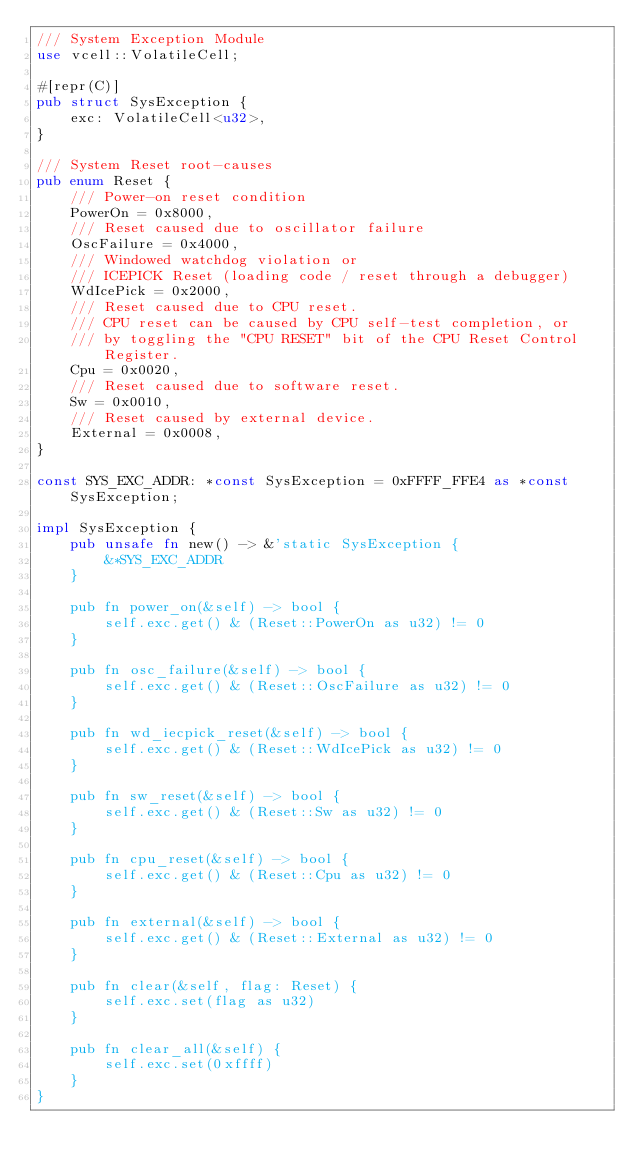<code> <loc_0><loc_0><loc_500><loc_500><_Rust_>/// System Exception Module
use vcell::VolatileCell;

#[repr(C)]
pub struct SysException {
    exc: VolatileCell<u32>,
}

/// System Reset root-causes
pub enum Reset {
    /// Power-on reset condition
    PowerOn = 0x8000,
    /// Reset caused due to oscillator failure
    OscFailure = 0x4000,
    /// Windowed watchdog violation or
    /// ICEPICK Reset (loading code / reset through a debugger)
    WdIcePick = 0x2000,
    /// Reset caused due to CPU reset.
    /// CPU reset can be caused by CPU self-test completion, or
    /// by toggling the "CPU RESET" bit of the CPU Reset Control Register.
    Cpu = 0x0020,
    /// Reset caused due to software reset.
    Sw = 0x0010,
    /// Reset caused by external device.
    External = 0x0008,
}

const SYS_EXC_ADDR: *const SysException = 0xFFFF_FFE4 as *const SysException;

impl SysException {
    pub unsafe fn new() -> &'static SysException {
        &*SYS_EXC_ADDR
    }

    pub fn power_on(&self) -> bool {
        self.exc.get() & (Reset::PowerOn as u32) != 0
    }

    pub fn osc_failure(&self) -> bool {
        self.exc.get() & (Reset::OscFailure as u32) != 0
    }

    pub fn wd_iecpick_reset(&self) -> bool {
        self.exc.get() & (Reset::WdIcePick as u32) != 0
    }

    pub fn sw_reset(&self) -> bool {
        self.exc.get() & (Reset::Sw as u32) != 0
    }

    pub fn cpu_reset(&self) -> bool {
        self.exc.get() & (Reset::Cpu as u32) != 0
    }

    pub fn external(&self) -> bool {
        self.exc.get() & (Reset::External as u32) != 0
    }

    pub fn clear(&self, flag: Reset) {
        self.exc.set(flag as u32)
    }

    pub fn clear_all(&self) {
        self.exc.set(0xffff)
    }
}
</code> 